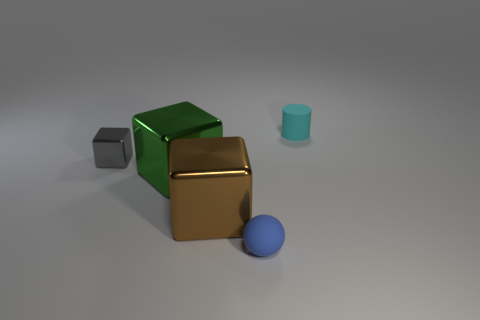How might these objects be used in a physics simulation? In a physics simulation, these objects could be used to demonstrate principles like collision, gravity, friction, and material interaction. For example, simulating how they fall or stack upon each other could illustrate stability and balance. 